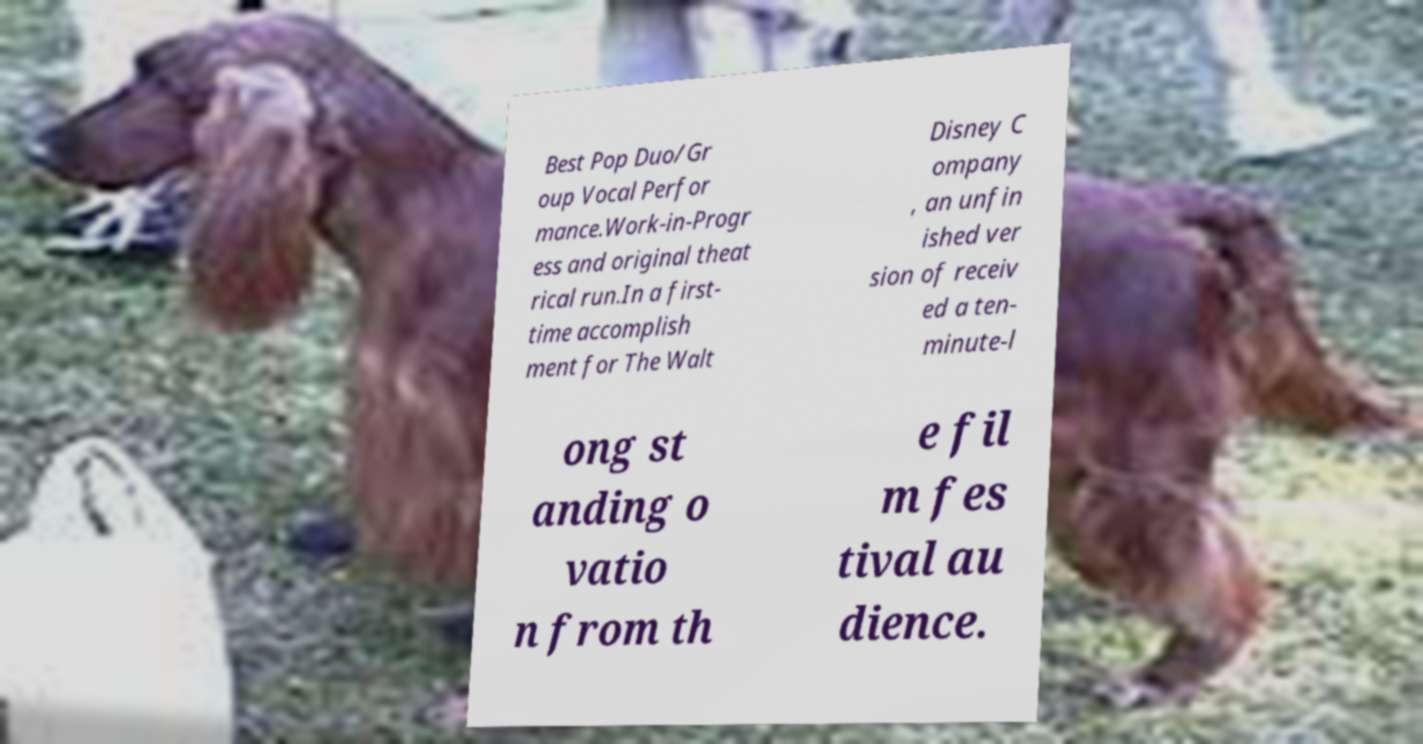Can you accurately transcribe the text from the provided image for me? Best Pop Duo/Gr oup Vocal Perfor mance.Work-in-Progr ess and original theat rical run.In a first- time accomplish ment for The Walt Disney C ompany , an unfin ished ver sion of receiv ed a ten- minute-l ong st anding o vatio n from th e fil m fes tival au dience. 